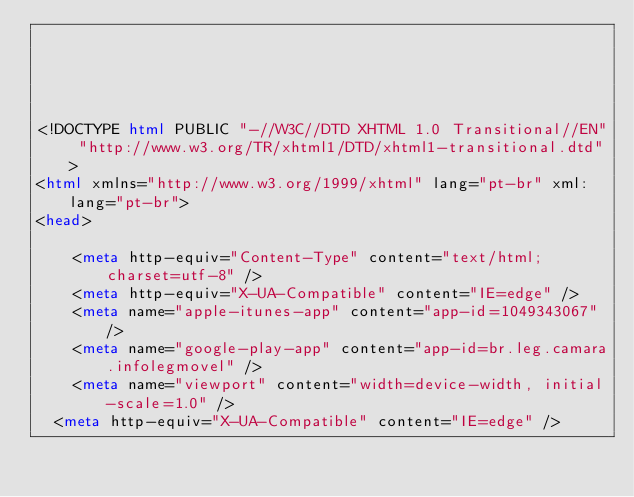Convert code to text. <code><loc_0><loc_0><loc_500><loc_500><_HTML_>




<!DOCTYPE html PUBLIC "-//W3C//DTD XHTML 1.0 Transitional//EN" "http://www.w3.org/TR/xhtml1/DTD/xhtml1-transitional.dtd">
<html xmlns="http://www.w3.org/1999/xhtml" lang="pt-br" xml:lang="pt-br">
<head>
	    
    <meta http-equiv="Content-Type" content="text/html; charset=utf-8" />
    <meta http-equiv="X-UA-Compatible" content="IE=edge" />
    <meta name="apple-itunes-app" content="app-id=1049343067" />
    <meta name="google-play-app" content="app-id=br.leg.camara.infolegmovel" />
    <meta name="viewport" content="width=device-width, initial-scale=1.0" />
	<meta http-equiv="X-UA-Compatible" content="IE=edge" /> 
    </code> 